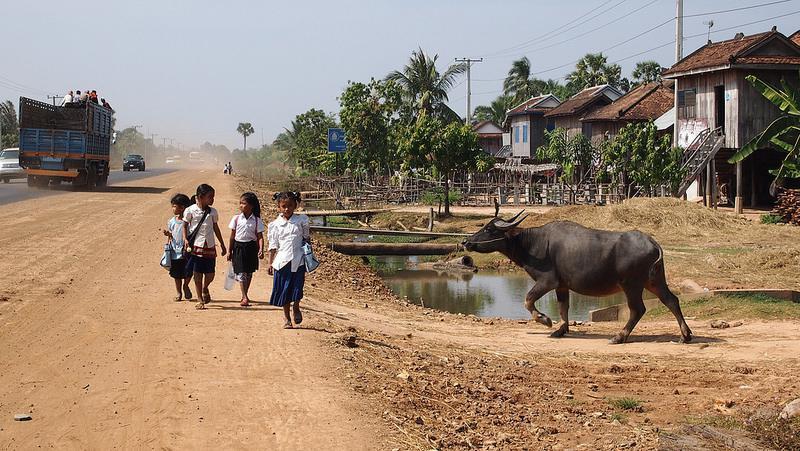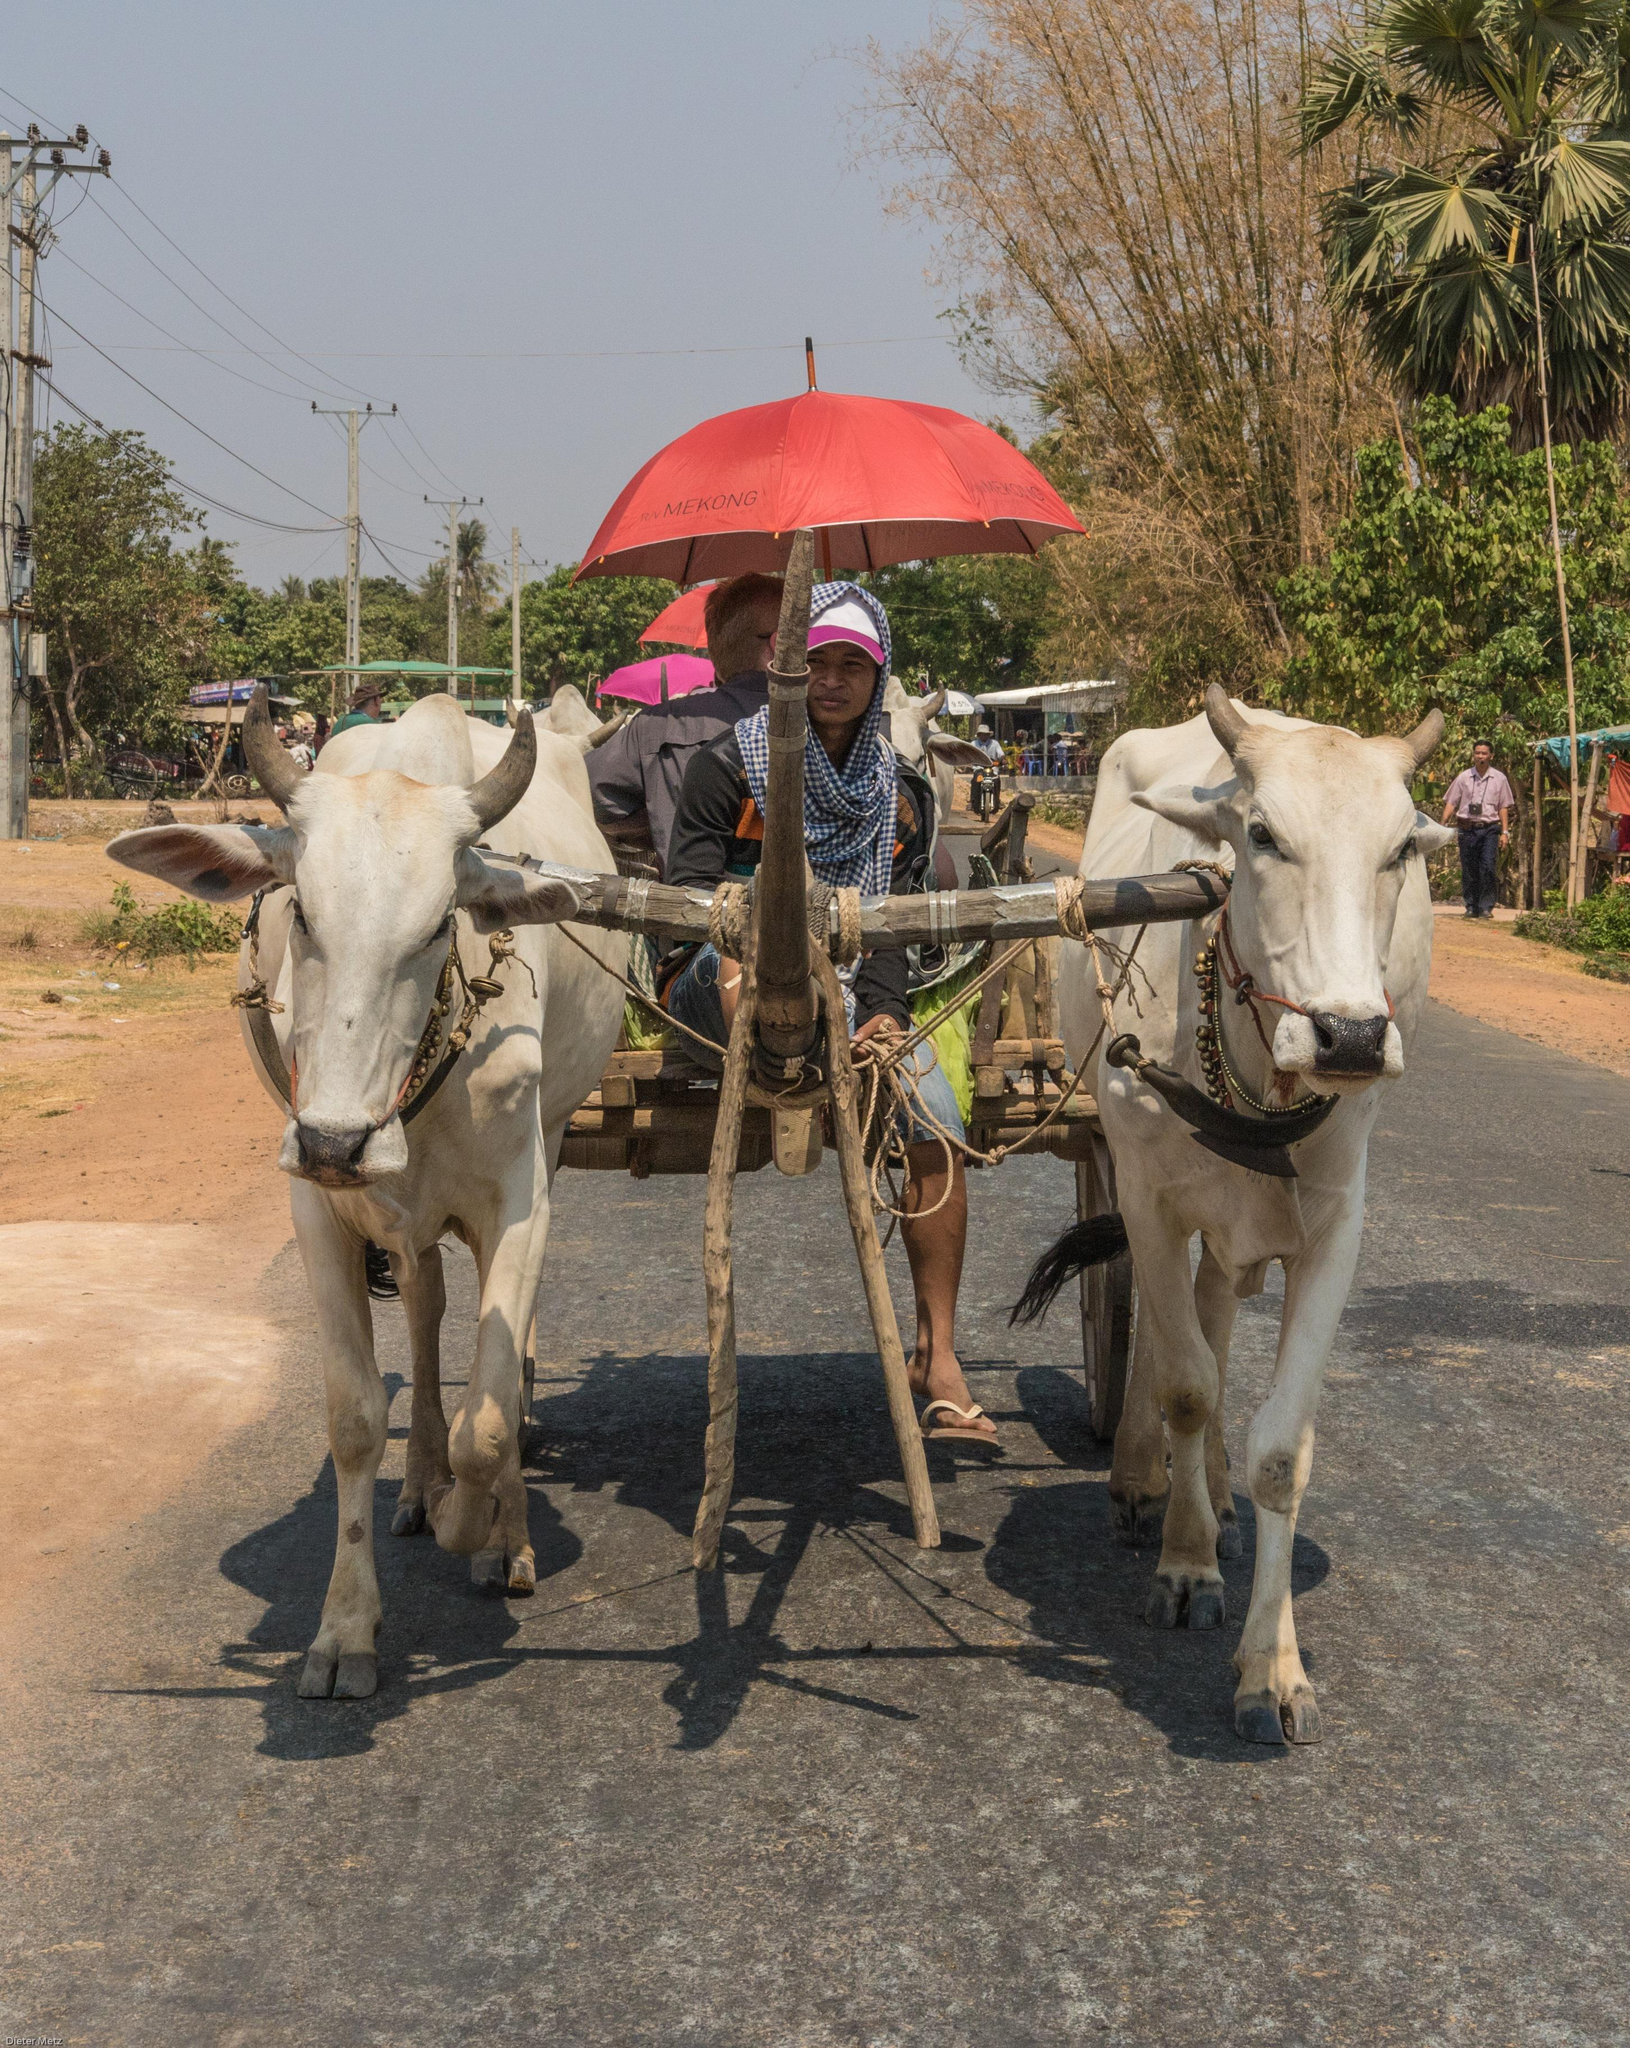The first image is the image on the left, the second image is the image on the right. For the images shown, is this caption "There is an ox in the water." true? Answer yes or no. No. The first image is the image on the left, the second image is the image on the right. Considering the images on both sides, is "An umbrella hovers over the cart in one of the images." valid? Answer yes or no. Yes. 